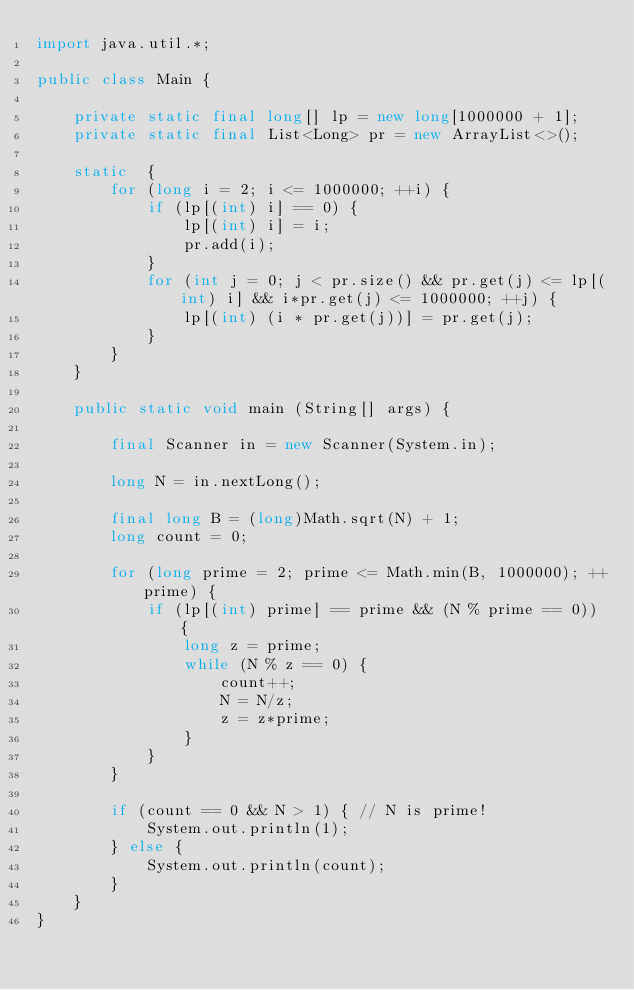Convert code to text. <code><loc_0><loc_0><loc_500><loc_500><_Java_>import java.util.*;

public class Main {

    private static final long[] lp = new long[1000000 + 1];
    private static final List<Long> pr = new ArrayList<>();

    static  {
        for (long i = 2; i <= 1000000; ++i) {
            if (lp[(int) i] == 0) {
                lp[(int) i] = i;
                pr.add(i);
            }
            for (int j = 0; j < pr.size() && pr.get(j) <= lp[(int) i] && i*pr.get(j) <= 1000000; ++j) {
                lp[(int) (i * pr.get(j))] = pr.get(j);
            }
        }
    }

    public static void main (String[] args) {

        final Scanner in = new Scanner(System.in);

        long N = in.nextLong();

        final long B = (long)Math.sqrt(N) + 1;
        long count = 0;

        for (long prime = 2; prime <= Math.min(B, 1000000); ++prime) {
            if (lp[(int) prime] == prime && (N % prime == 0)) {
                long z = prime;
                while (N % z == 0) {
                    count++;
                    N = N/z;
                    z = z*prime;
                }
            }
        }

        if (count == 0 && N > 1) { // N is prime!
            System.out.println(1);
        } else {
            System.out.println(count);
        }
    }
}</code> 